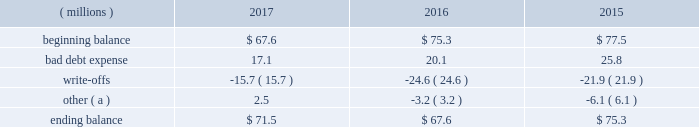Cash and cash equivalents cash equivalents include highly-liquid investments with a maturity of three months or less when purchased .
Accounts receivable and allowance for doubtful accounts accounts receivable are carried at the invoiced amounts , less an allowance for doubtful accounts , and generally do not bear interest .
The company estimates the balance of allowance for doubtful accounts by analyzing accounts receivable balances by age and applying historical write-off and collection trend rates .
The company 2019s estimates include separately providing for customer receivables based on specific circumstances and credit conditions , and when it is deemed probable that the balance is uncollectible .
Account balances are written off against the allowance when it is determined the receivable will not be recovered .
The company 2019s allowance for doubtful accounts balance also includes an allowance for the expected return of products shipped and credits related to pricing or quantities shipped of $ 15 million , $ 14 million and $ 15 million as of december 31 , 2017 , 2016 , and 2015 , respectively .
Returns and credit activity is recorded directly to sales as a reduction .
The table summarizes the activity in the allowance for doubtful accounts: .
( a ) other amounts are primarily the effects of changes in currency translations and the impact of allowance for returns and credits .
Inventory valuations inventories are valued at the lower of cost or net realizable value .
Certain u.s .
Inventory costs are determined on a last-in , first-out ( 201clifo 201d ) basis .
Lifo inventories represented 39% ( 39 % ) and 40% ( 40 % ) of consolidated inventories as of december 31 , 2017 and 2016 , respectively .
All other inventory costs are determined using either the average cost or first-in , first-out ( 201cfifo 201d ) methods .
Inventory values at fifo , as shown in note 5 , approximate replacement cost .
Property , plant and equipment property , plant and equipment assets are stated at cost .
Merchandising and customer equipment consists principally of various dispensing systems for the company 2019s cleaning and sanitizing products , dishwashing machines and process control and monitoring equipment .
Certain dispensing systems capitalized by the company are accounted for on a mass asset basis , whereby equipment is capitalized and depreciated as a group and written off when fully depreciated .
The company capitalizes both internal and external costs of development or purchase of computer software for internal use .
Costs incurred for data conversion , training and maintenance associated with capitalized software are expensed as incurred .
Expenditures for major renewals and improvements , which significantly extend the useful lives of existing plant and equipment , are capitalized and depreciated .
Expenditures for repairs and maintenance are charged to expense as incurred .
Upon retirement or disposition of plant and equipment , the cost and related accumulated depreciation are removed from the accounts and any resulting gain or loss is recognized in income .
Depreciation is charged to operations using the straight-line method over the assets 2019 estimated useful lives ranging from 5 to 40 years for buildings and leasehold improvements , 3 to 20 years for machinery and equipment , 3 to 15 years for merchandising and customer equipment and 3 to 7 years for capitalized software .
The straight-line method of depreciation reflects an appropriate allocation of the cost of the assets to earnings in proportion to the amount of economic benefits obtained by the company in each reporting period .
Depreciation expense was $ 586 million , $ 561 million and $ 560 million for 2017 , 2016 and 2015 , respectively. .
The company 2019s allowance for doubtful accounts balance also includes an allowance for the expected return of products shipped and credits related to pricing or quantities shipped . as of december 31 , 2017 , what percentage of the ending balance is this? 
Computations: (15 / 71.5)
Answer: 0.20979. 